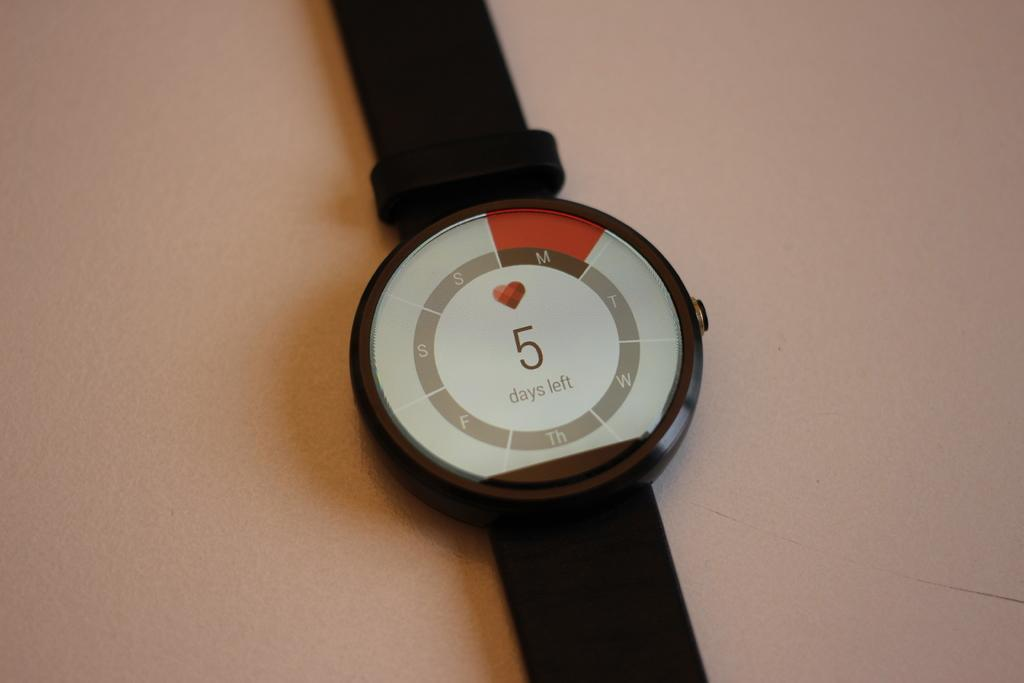Provide a one-sentence caption for the provided image. A watch that shows that there are currently 5 days left. 